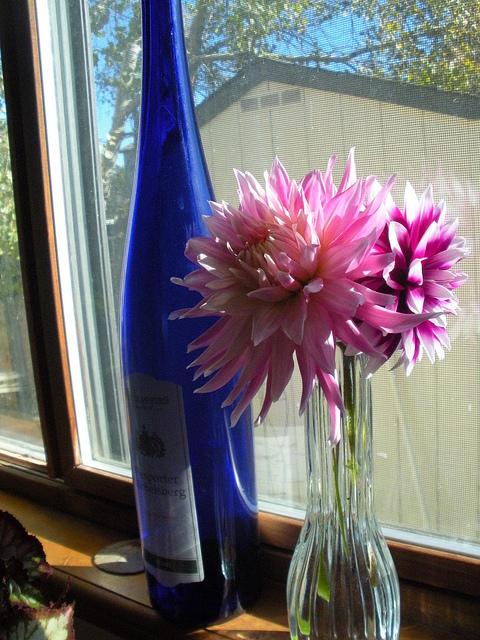Is the vase or wine bottle taller?
Short answer required. Wine bottle. Which way does the window open?
Be succinct. Sideways. What color are the leaves?
Concise answer only. Pink. What kind of flowers are these?
Give a very brief answer. Hydrangea. 